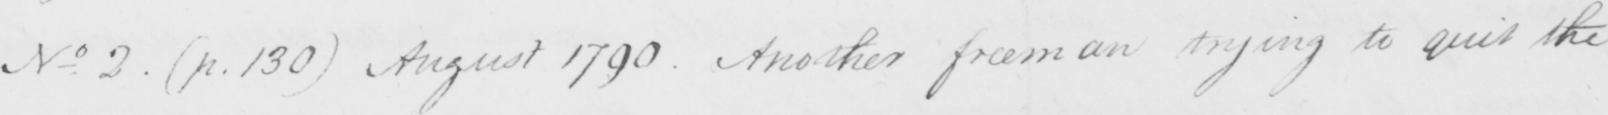Please provide the text content of this handwritten line. No . 2  ( p . 130 )  August 1790 . Another freeman trying to quit the 